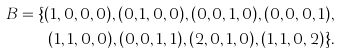Convert formula to latex. <formula><loc_0><loc_0><loc_500><loc_500>B = \{ ( 1 , 0 , 0 , 0 ) , ( 0 , 1 , 0 , 0 ) , ( 0 , 0 , 1 , 0 ) , ( 0 , 0 , 0 , 1 ) , & \\ ( 1 , 1 , 0 , 0 ) , ( 0 , 0 , 1 , 1 ) , ( 2 , 0 , 1 , 0 ) , ( 1 , 1 , 0 , 2 ) \} .</formula> 